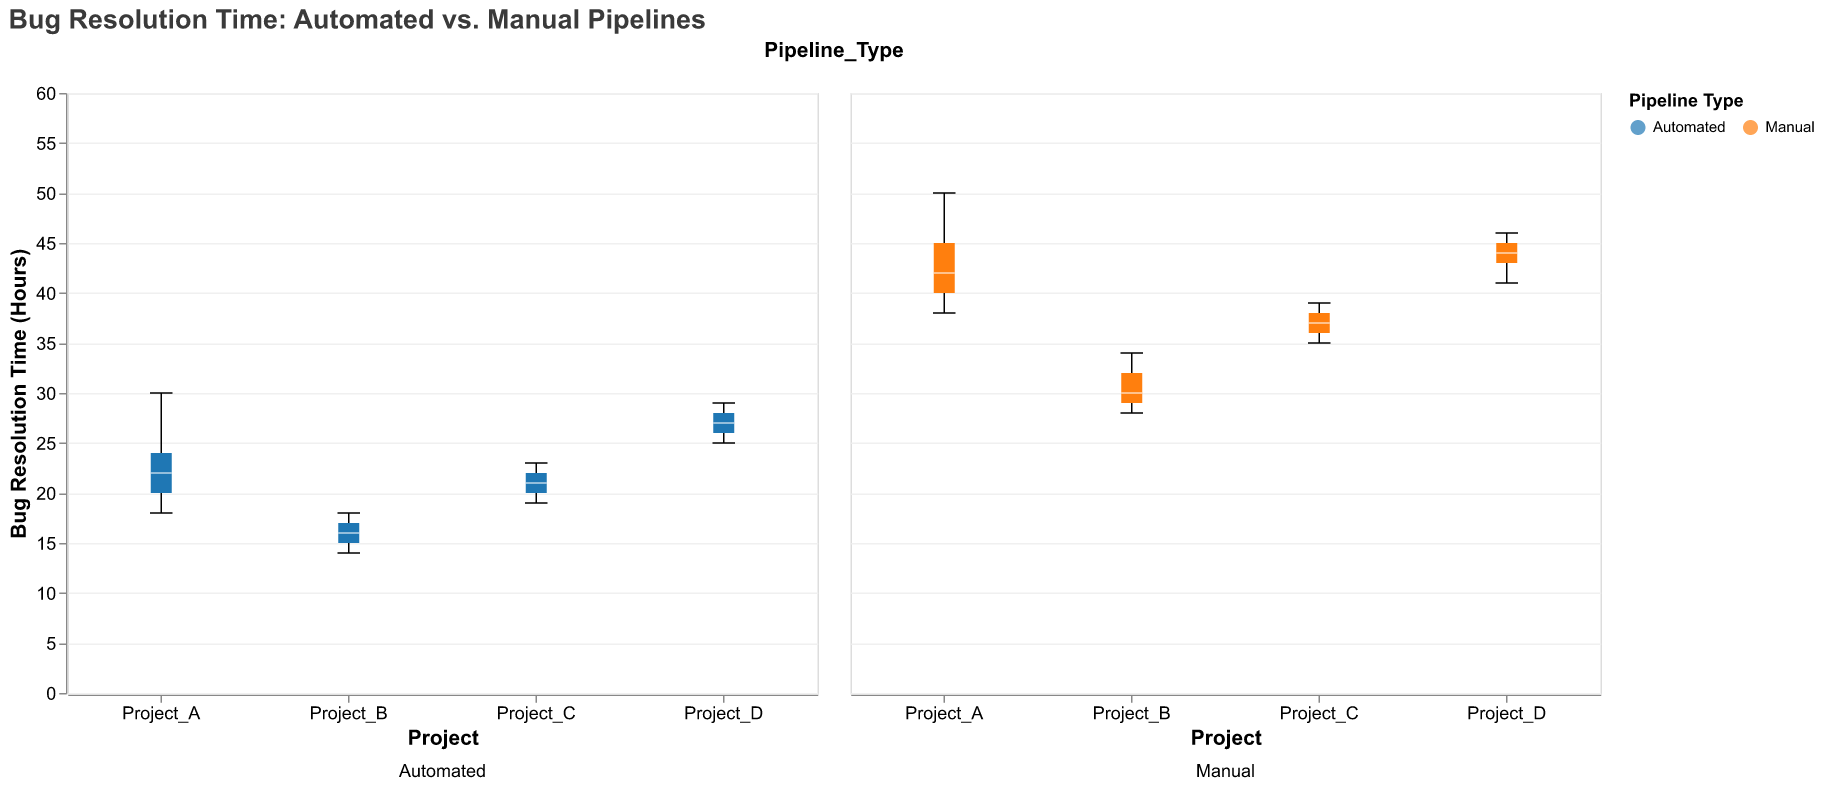What is the title of the plot? The title of the plot is presented at the top and gives information about the figure's primary focus.
Answer: Bug Resolution Time: Automated vs. Manual Pipelines What are the x-axis and y-axis labels? The x-axis label is "Project," and the y-axis label is "Bug Resolution Time (Hours)." These labels are visible on the horizontal and vertical sides of the plot respectively.
Answer: Project; Bug Resolution Time (Hours) What do the colors in the plot represent? The colors in the plot represent the different pipeline types. Blue corresponds to Automated pipelines, and orange corresponds to Manual pipelines. This is shown in the legend.
Answer: Pipeline Types Which project has the highest median bug resolution time in manual pipelines? Look for the median line (white) in the box plots corresponding to the manual pipelines for each project. Project_D has the highest median bug resolution time.
Answer: Project_D Which project shows the least variation in bug resolution times for automated pipelines? Check the width of the box in the boxplot for automated pipelines across projects. Project_B has the least variation as its box is the narrowest.
Answer: Project_B What is the range of bug resolution times for automated pipelines in Project_A? The range for automated pipelines in Project_A can be determined by looking at the extreme points of the whiskers in the box plot. The range is from 18 to 30 hours.
Answer: 18 to 30 hours Compare the median bug resolution time between automated and manual pipelines for Project_C. Identify the median line (white) in the box plots for both pipeline types in Project_C. The median for automated is around 21 hours, and for manual, it is around 37 hours.
Answer: Automated: 21 hours, Manual: 37 hours Which pipeline type generally has shorter bug resolution times? Compare the medians of the automated and manual pipelines across all projects. Automated pipelines generally show shorter bug resolution times, as their medians are consistently lower than those of manual pipelines.
Answer: Automated What is the difference in median bug resolution time between automated and manual pipelines for Project_D? Determine the median lines in the boxplot for Project_D: the median for automated is around 27 hours, and for manual, it is around 44 hours. Calculate the difference: 44 - 27 = 17 hours.
Answer: 17 hours 